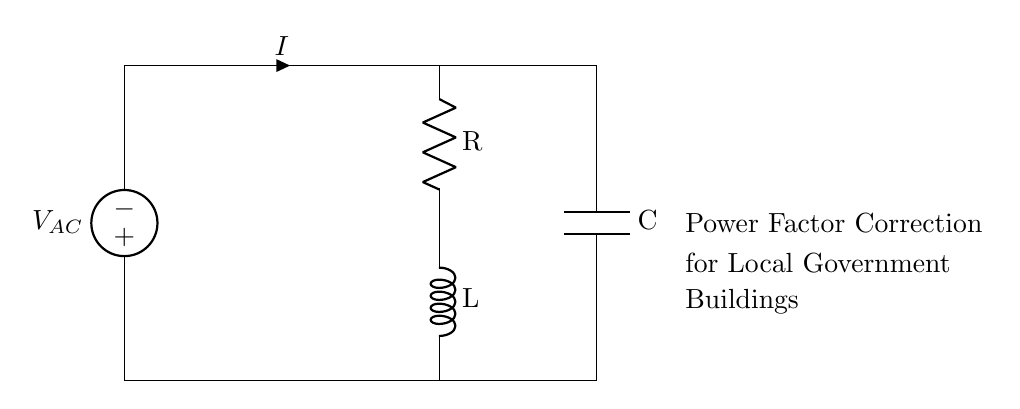What is the voltage source in this circuit? The voltage source is represented by V AC, which is the first component in the diagram, providing AC voltage to the circuit.
Answer: V AC What components are connected in series in this circuit? The circuit components R (resistor), L (inductor), and the voltage source V AC are connected in series, meaning current flows through them one after the other.
Answer: R, L, V AC What does the capacitor do in this circuit? The capacitor (C) is used for power factor correction in the circuit by storing and releasing electrical energy, which helps improve the efficiency of the circuit.
Answer: Power factor correction What is the purpose of the inductor in this circuit? The inductor (L) influences the current flow by storing energy in a magnetic field when current passes through it, which helps in controlling the power factor in the circuit.
Answer: Current control How is power factor correction achieved in this circuit? Power factor correction is achieved by adding the capacitor (C) in parallel with the load, which offsets the inductive reactance of the circuit and improves the overall power factor.
Answer: Capacitor parallel What is the role of the resistor in the RLC circuit? The resistor (R) dissipates energy in the form of heat, regulating the amount of current in the circuit while contributing to the overall resistance and power factor.
Answer: Energy dissipation 